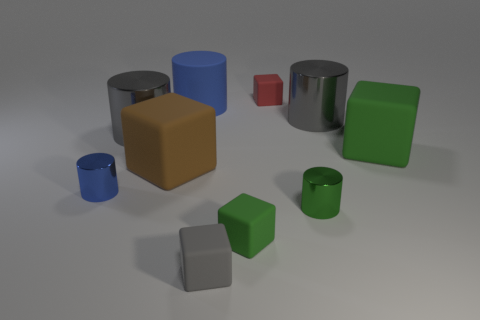Subtract 1 blocks. How many blocks are left? 4 Subtract 0 red cylinders. How many objects are left? 10 Subtract all large gray matte things. Subtract all small red things. How many objects are left? 9 Add 4 brown objects. How many brown objects are left? 5 Add 2 tiny gray things. How many tiny gray things exist? 3 